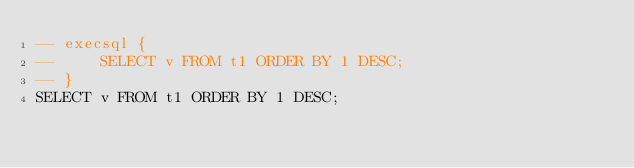Convert code to text. <code><loc_0><loc_0><loc_500><loc_500><_SQL_>-- execsql {
--     SELECT v FROM t1 ORDER BY 1 DESC;
-- }
SELECT v FROM t1 ORDER BY 1 DESC;</code> 